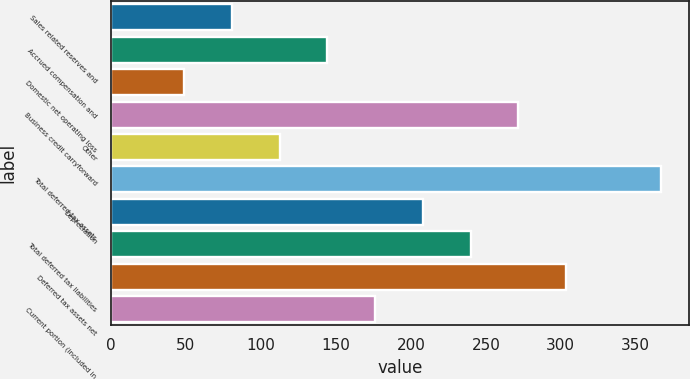Convert chart. <chart><loc_0><loc_0><loc_500><loc_500><bar_chart><fcel>Sales related reserves and<fcel>Accrued compensation and<fcel>Domestic net operating loss<fcel>Business credit carryforward<fcel>Other<fcel>Total deferred tax assets<fcel>Depreciation<fcel>Total deferred tax liabilities<fcel>Deferred tax assets net<fcel>Current portion (included in<nl><fcel>80.8<fcel>144.4<fcel>49<fcel>271.6<fcel>112.6<fcel>367<fcel>208<fcel>239.8<fcel>303.4<fcel>176.2<nl></chart> 